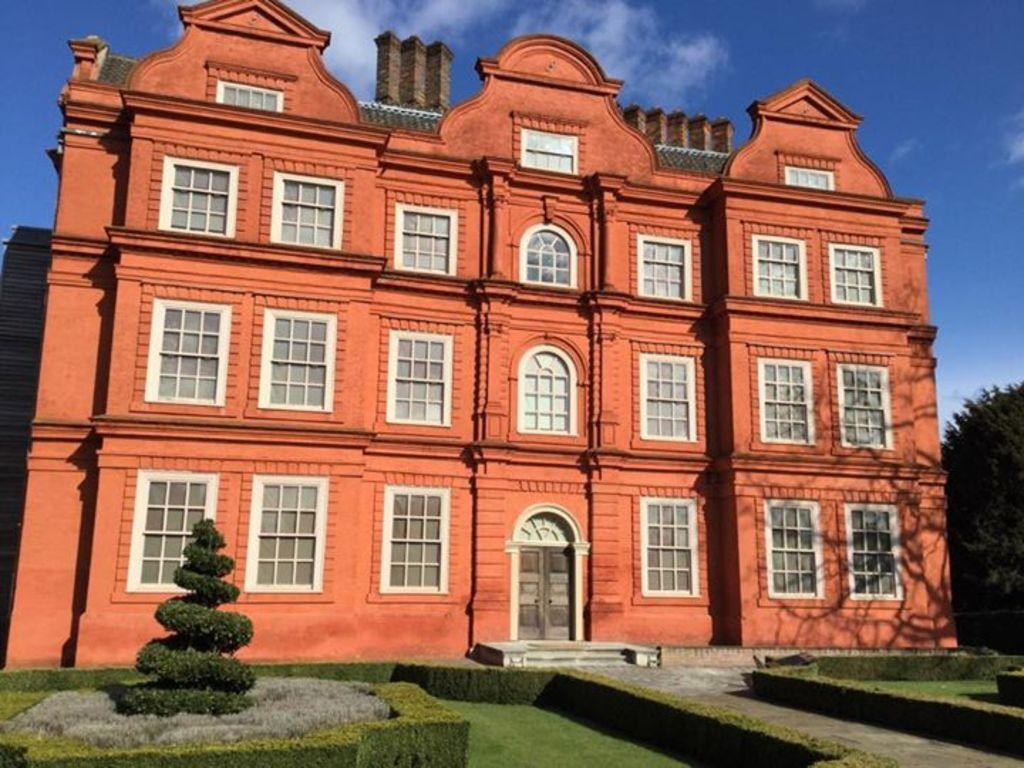What type of structure is present in the image? There is a building in the image. What features can be seen on the building? The building has windows and a door. What other objects are visible in the image? There are trees and stairs in the image. What is the color of the sky in the image? The sky is blue and white in color. How many geese are flying in the image? There are no geese present in the image. What type of mask is being worn by the building in the image? There is no mask present in the image, as it features a building with windows, a door, trees, stairs, and a blue and white sky. 